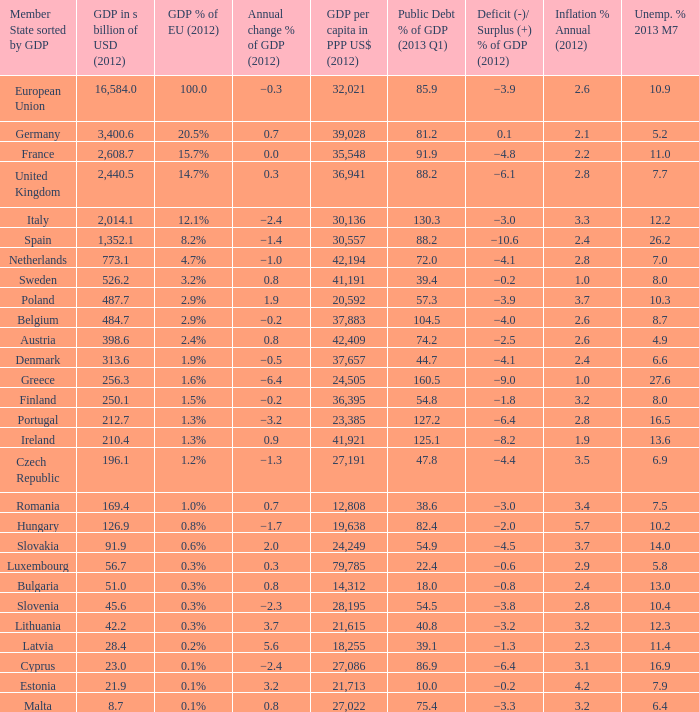In 2012, what was the highest annual inflation percentage in a country that had a public debt percentage of gdp greater than 88.2 in 2013 q1 and a gdp percentage of the eu of 2.9%? 2.6. 